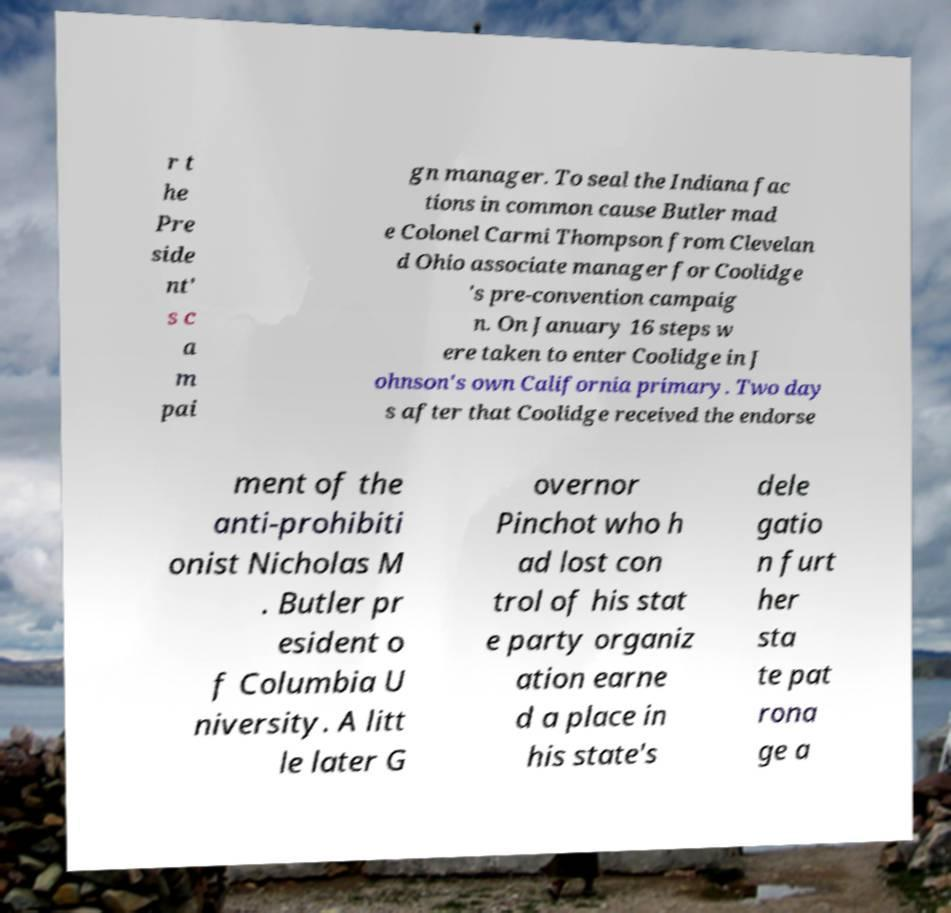I need the written content from this picture converted into text. Can you do that? r t he Pre side nt' s c a m pai gn manager. To seal the Indiana fac tions in common cause Butler mad e Colonel Carmi Thompson from Clevelan d Ohio associate manager for Coolidge 's pre-convention campaig n. On January 16 steps w ere taken to enter Coolidge in J ohnson's own California primary. Two day s after that Coolidge received the endorse ment of the anti-prohibiti onist Nicholas M . Butler pr esident o f Columbia U niversity. A litt le later G overnor Pinchot who h ad lost con trol of his stat e party organiz ation earne d a place in his state's dele gatio n furt her sta te pat rona ge a 